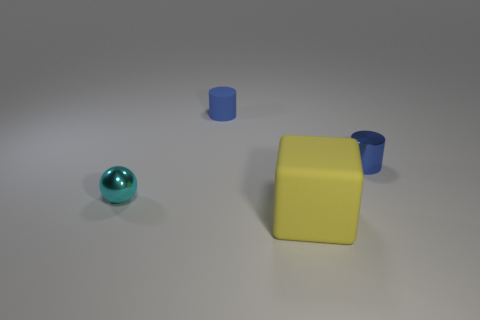Add 3 tiny cylinders. How many objects exist? 7 Subtract all blocks. How many objects are left? 3 Subtract 2 blue cylinders. How many objects are left? 2 Subtract all blue objects. Subtract all tiny brown matte spheres. How many objects are left? 2 Add 1 matte things. How many matte things are left? 3 Add 4 metallic balls. How many metallic balls exist? 5 